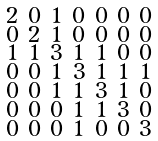Convert formula to latex. <formula><loc_0><loc_0><loc_500><loc_500>\begin{smallmatrix} 2 & 0 & 1 & 0 & 0 & 0 & 0 \\ 0 & 2 & 1 & 0 & 0 & 0 & 0 \\ 1 & 1 & 3 & 1 & 1 & 0 & 0 \\ 0 & 0 & 1 & 3 & 1 & 1 & 1 \\ 0 & 0 & 1 & 1 & 3 & 1 & 0 \\ 0 & 0 & 0 & 1 & 1 & 3 & 0 \\ 0 & 0 & 0 & 1 & 0 & 0 & 3 \end{smallmatrix}</formula> 